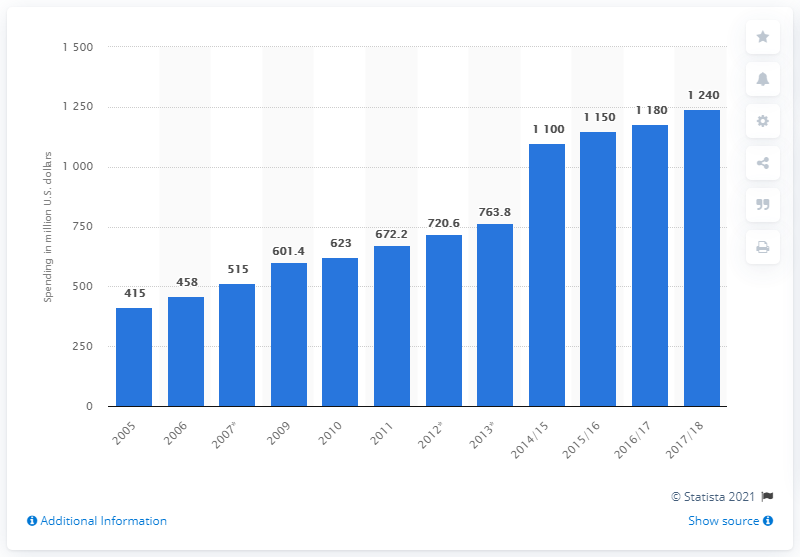Specify some key components in this picture. In the United States during the 2017/18 academic year, a total of $1240 million was spent on college sports sponsorship. 